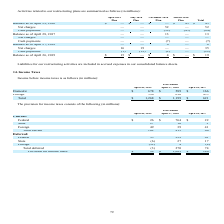According to Netapp's financial document, What does the table show? Income before income taxes. The document states: "Income before income taxes is as follows (in millions): Year Ended..." Also, What was the foreign income before income taxes in 2018? According to the financial document, 610 (in millions). The relevant text states: "Foreign 590 610 455..." Also, What was the total income before income taxes in 2017? According to the financial document, 621 (in millions). The relevant text states: "Total $ 1,268 $ 1,199 $ 621..." Also, can you calculate: What was the change in foreign income before income taxes between 2017 and 2018? Based on the calculation: 610-455, the result is 155 (in millions). This is based on the information: "Foreign 590 610 455 Foreign 590 610 455..." The key data points involved are: 455, 610. Also, can you calculate: What was the change in foreign income before income taxes between 2018 and 2019? Based on the calculation: 590-610, the result is -20 (in millions). This is based on the information: "Foreign 590 610 455 Foreign 590 610 455..." The key data points involved are: 590, 610. Also, can you calculate: What was the percentage change in the total income before income taxes between 2018 and 2019? To answer this question, I need to perform calculations using the financial data. The calculation is: (1,268-1,199)/1,199, which equals 5.75 (percentage). This is based on the information: "Total $ 1,268 $ 1,199 $ 621 Total $ 1,268 $ 1,199 $ 621..." The key data points involved are: 1,199, 1,268. 